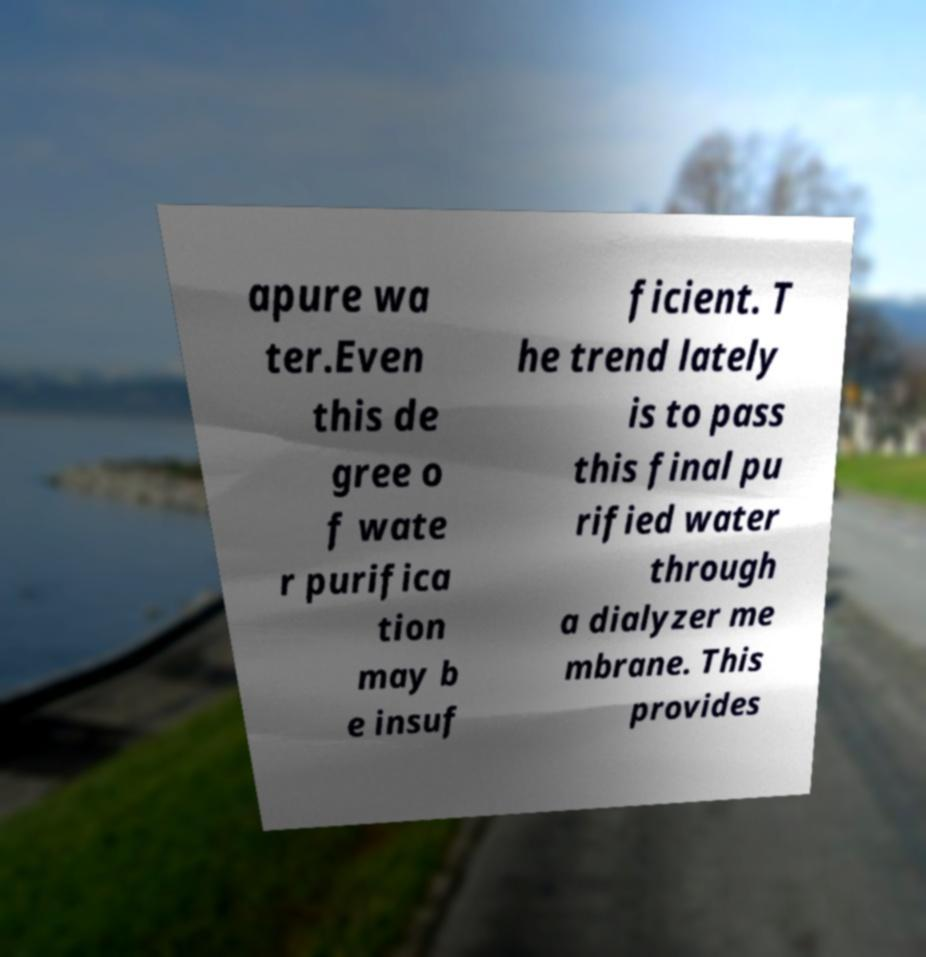Can you accurately transcribe the text from the provided image for me? apure wa ter.Even this de gree o f wate r purifica tion may b e insuf ficient. T he trend lately is to pass this final pu rified water through a dialyzer me mbrane. This provides 